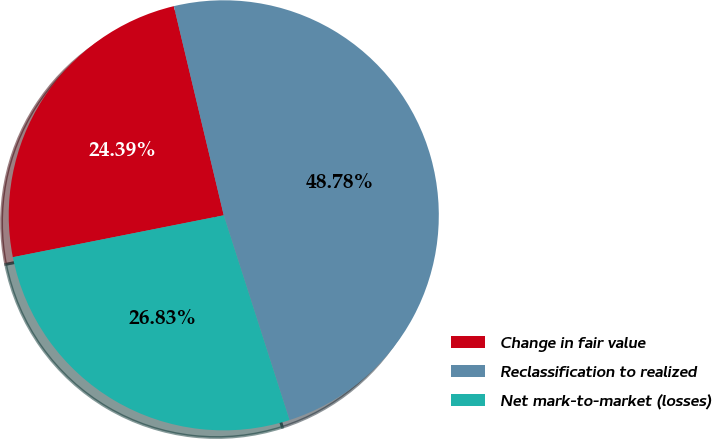<chart> <loc_0><loc_0><loc_500><loc_500><pie_chart><fcel>Change in fair value<fcel>Reclassification to realized<fcel>Net mark-to-market (losses)<nl><fcel>24.39%<fcel>48.78%<fcel>26.83%<nl></chart> 